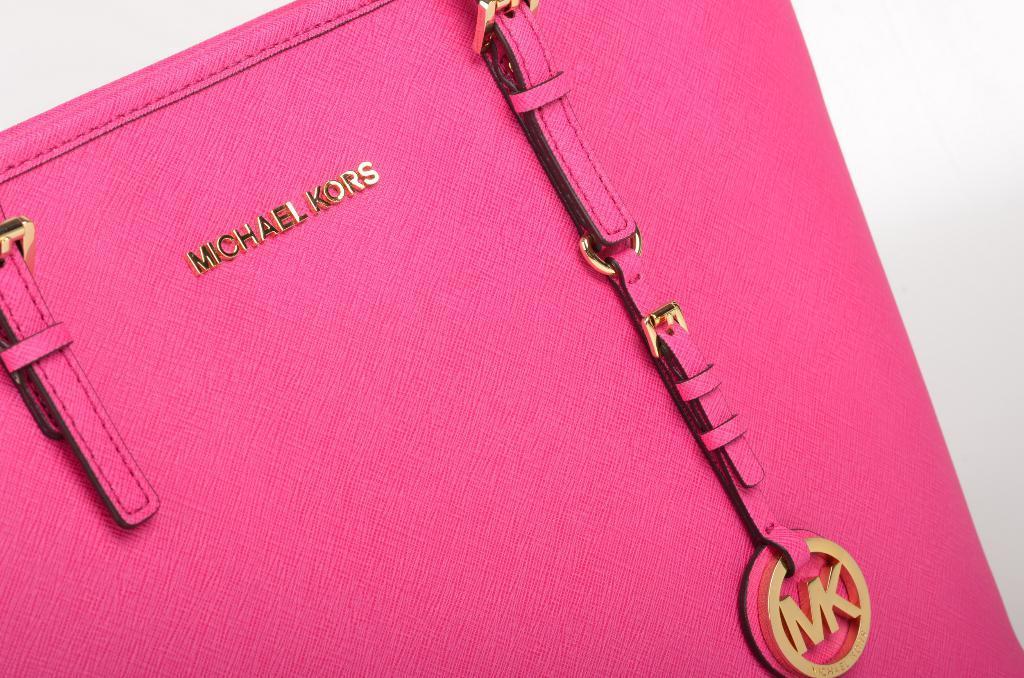Could you give a brief overview of what you see in this image? In this image there is a bag which is pink in colour with some text written on it. 